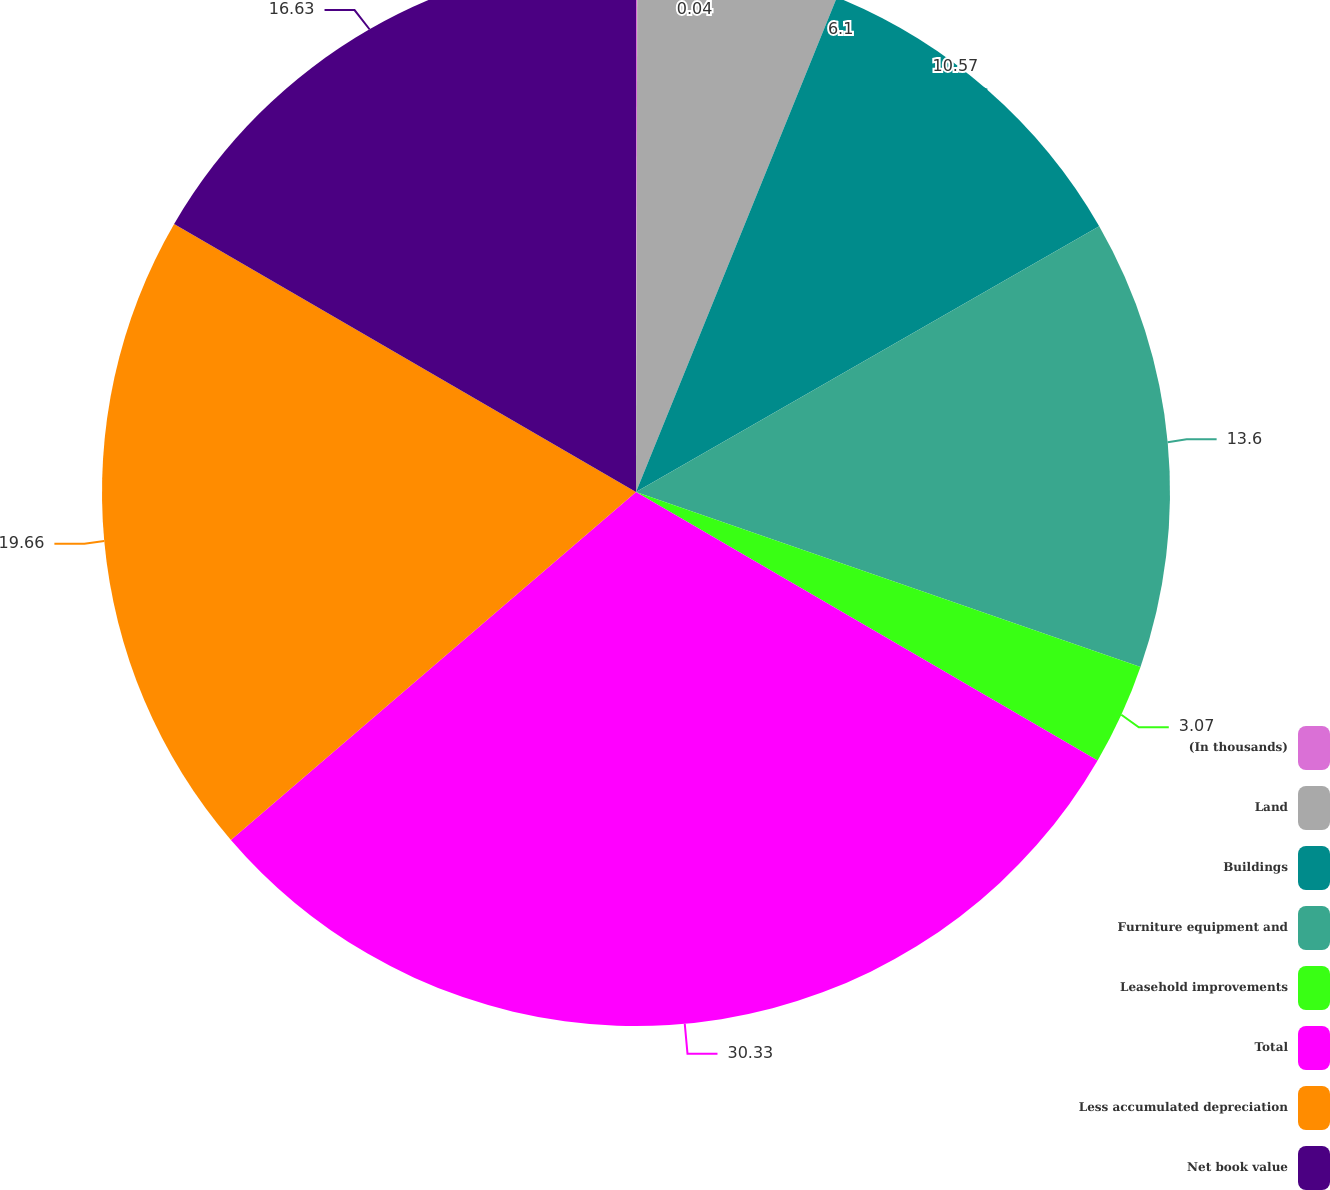Convert chart to OTSL. <chart><loc_0><loc_0><loc_500><loc_500><pie_chart><fcel>(In thousands)<fcel>Land<fcel>Buildings<fcel>Furniture equipment and<fcel>Leasehold improvements<fcel>Total<fcel>Less accumulated depreciation<fcel>Net book value<nl><fcel>0.04%<fcel>6.1%<fcel>10.57%<fcel>13.6%<fcel>3.07%<fcel>30.32%<fcel>19.66%<fcel>16.63%<nl></chart> 